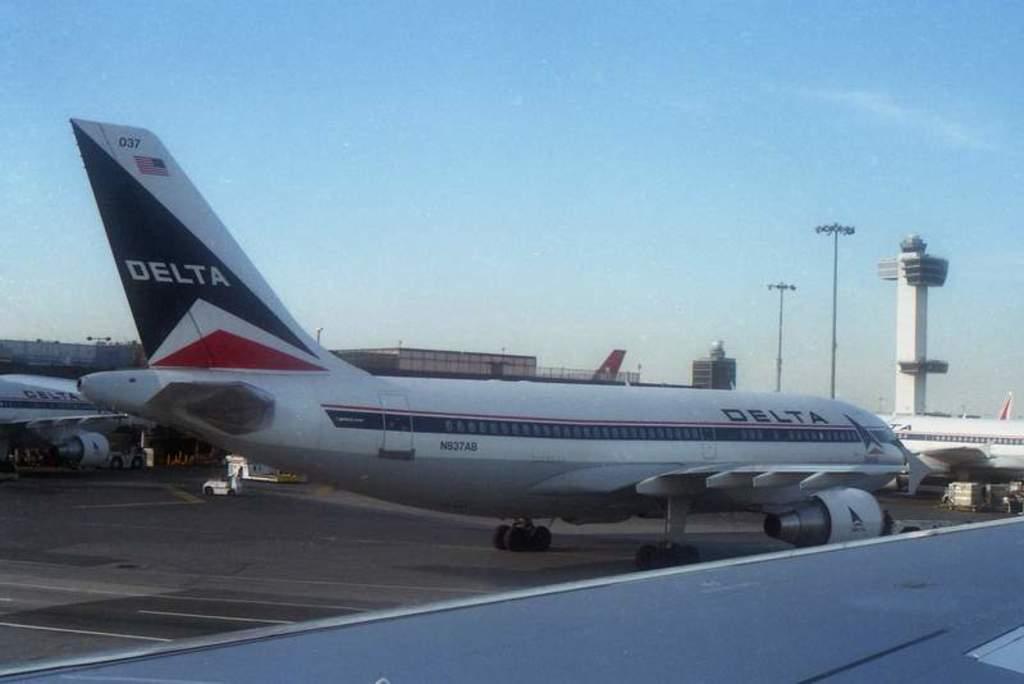Can you describe this image briefly? In this image I can see in the middle there is an aeroplane in white and blue color. It looks like an airport, at the top it is the sky. On the right side there are lights. 